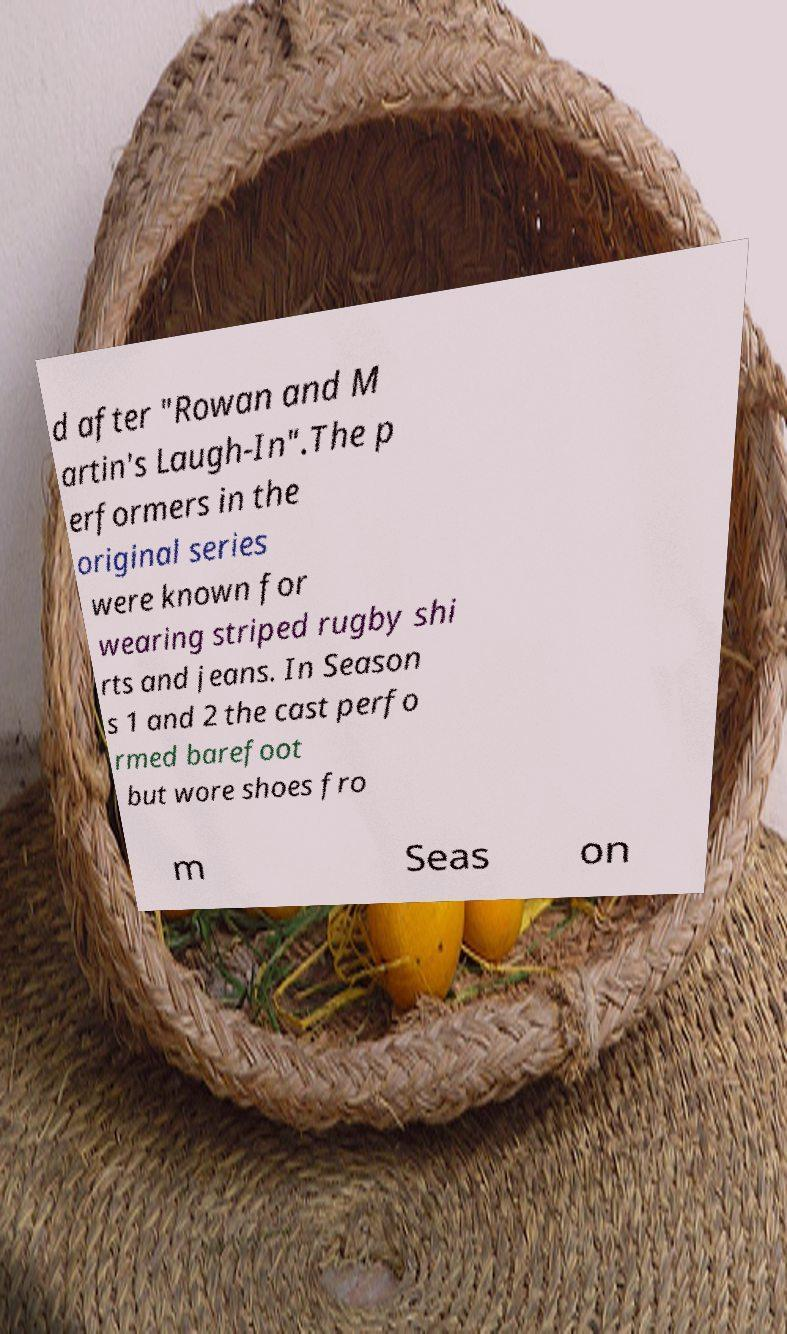Could you assist in decoding the text presented in this image and type it out clearly? d after "Rowan and M artin's Laugh-In".The p erformers in the original series were known for wearing striped rugby shi rts and jeans. In Season s 1 and 2 the cast perfo rmed barefoot but wore shoes fro m Seas on 